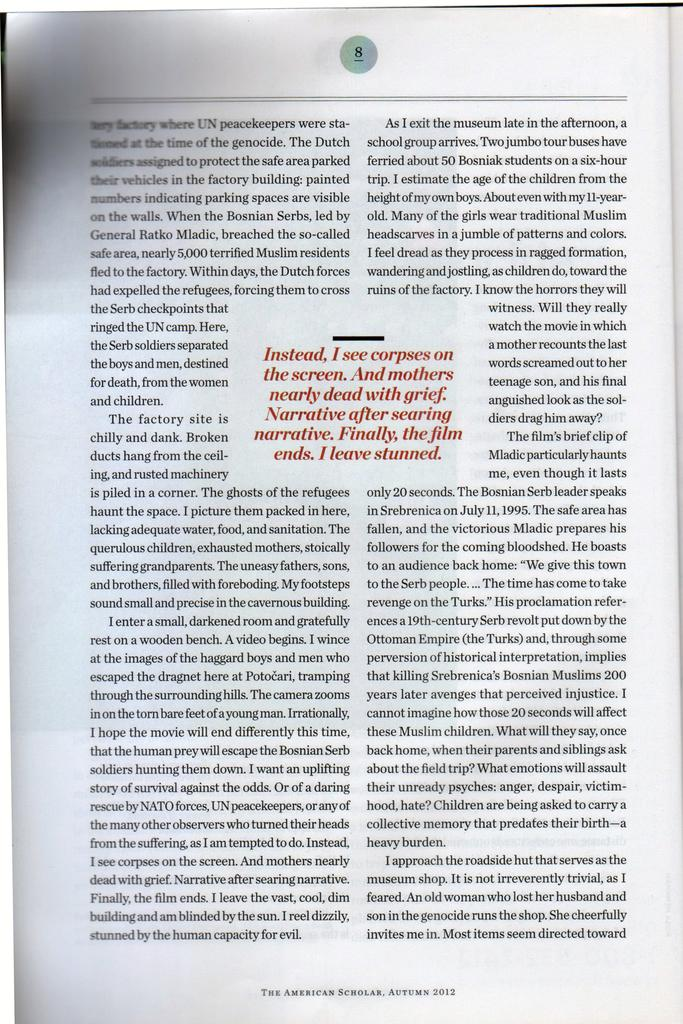<image>
Provide a brief description of the given image. Page 8 of American scholar autumn 2012 issue about NATO and UN Peacemaker 